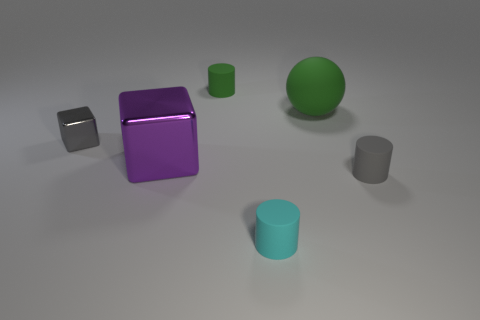What color is the tiny matte object behind the gray object in front of the cube that is on the right side of the tiny gray metal thing?
Your answer should be very brief. Green. Are there any tiny gray shiny things?
Your answer should be compact. Yes. How many other things are there of the same size as the gray metallic block?
Provide a short and direct response. 3. There is a sphere; does it have the same color as the tiny object that is behind the large green matte sphere?
Your response must be concise. Yes. What number of things are either large brown blocks or purple cubes?
Your answer should be very brief. 1. Is there anything else that is the same color as the big shiny object?
Your answer should be compact. No. Is the material of the tiny green cylinder the same as the tiny gray thing to the left of the green cylinder?
Your response must be concise. No. What shape is the green object on the right side of the tiny cylinder that is behind the tiny gray cylinder?
Offer a very short reply. Sphere. There is a thing that is both on the left side of the small green cylinder and to the right of the tiny gray metallic thing; what is its shape?
Provide a succinct answer. Cube. How many things are small gray metallic cubes or rubber cylinders that are behind the small shiny object?
Your answer should be compact. 2. 